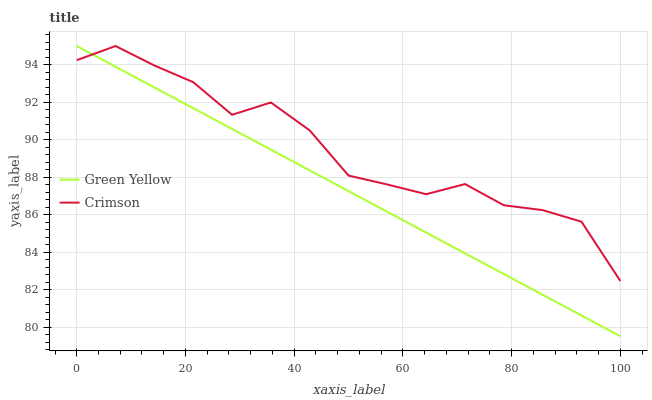Does Green Yellow have the maximum area under the curve?
Answer yes or no. No. Is Green Yellow the roughest?
Answer yes or no. No. 